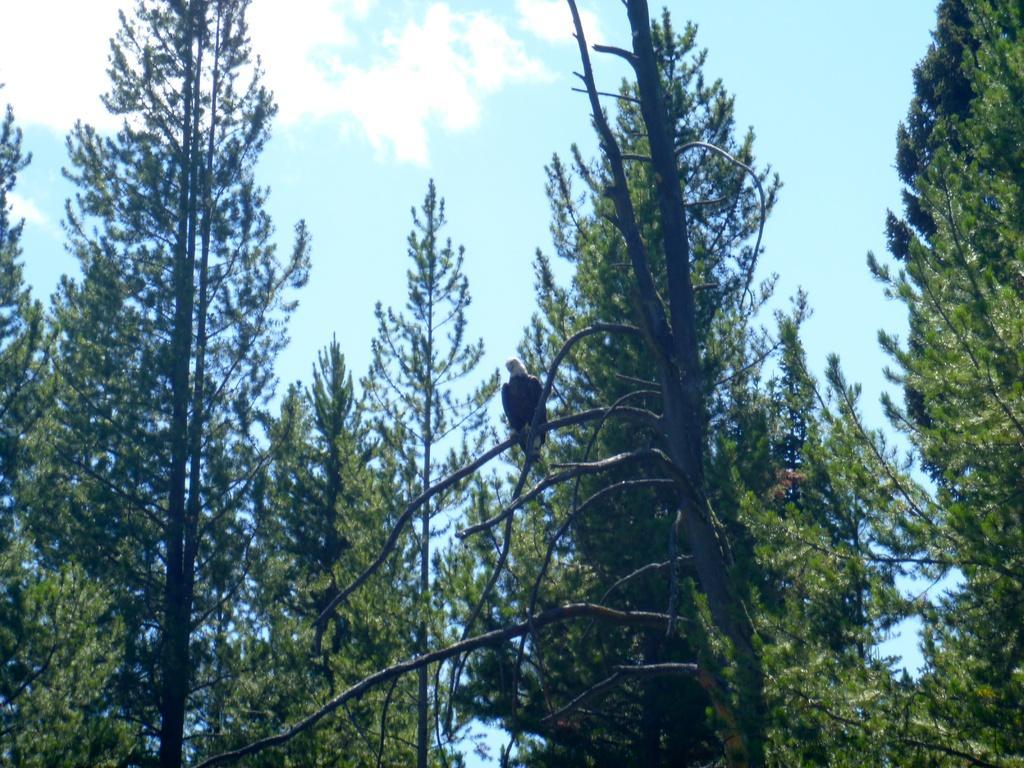In one or two sentences, can you explain what this image depicts? In this image there are many tall trees. There is a bird standing on a branch. There are clouds in the sky. 